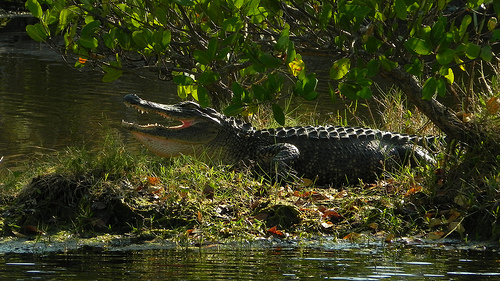<image>
Is there a crocodile in front of the tree? No. The crocodile is not in front of the tree. The spatial positioning shows a different relationship between these objects. 